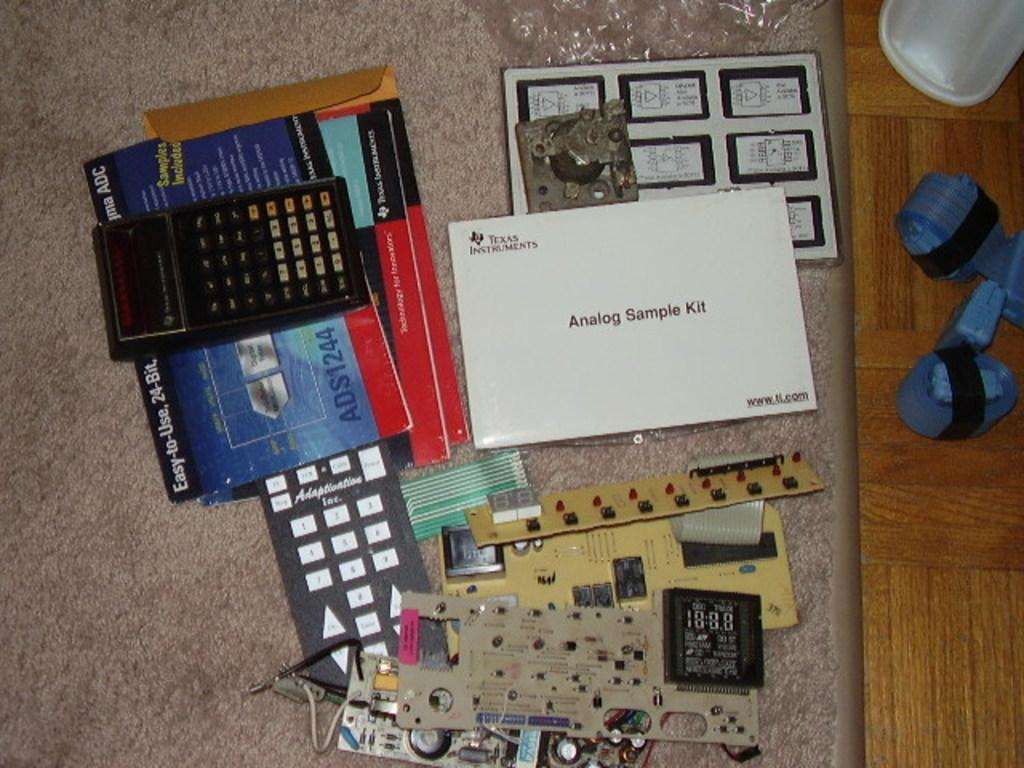Provide a one-sentence caption for the provided image. A white Texas Instrument Analog Sample Kit sits on a carpet with several calculators and electronic elements. 